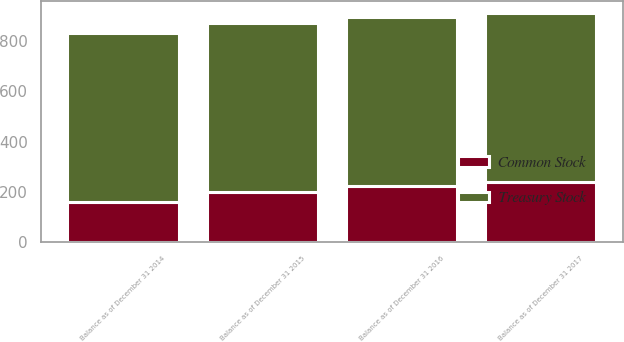Convert chart to OTSL. <chart><loc_0><loc_0><loc_500><loc_500><stacked_bar_chart><ecel><fcel>Balance as of December 31 2014<fcel>Balance as of December 31 2015<fcel>Balance as of December 31 2016<fcel>Balance as of December 31 2017<nl><fcel>Treasury Stock<fcel>673<fcel>673<fcel>673<fcel>673<nl><fcel>Common Stock<fcel>159<fcel>200<fcel>222<fcel>240<nl></chart> 